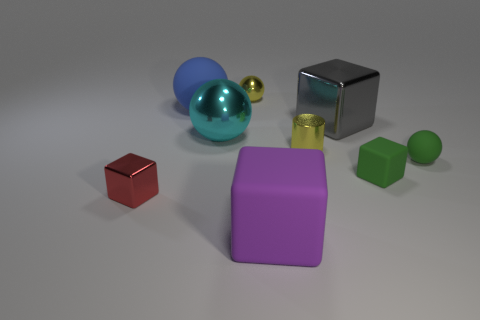There is a big cyan object that is made of the same material as the red object; what shape is it?
Give a very brief answer. Sphere. How many other objects are there of the same shape as the purple thing?
Your answer should be very brief. 3. There is a small yellow metallic object in front of the big matte thing that is left of the large block in front of the tiny green matte sphere; what is its shape?
Your response must be concise. Cylinder. What number of cylinders are big purple rubber things or large gray metal things?
Make the answer very short. 0. There is a metal ball that is to the left of the small yellow sphere; are there any tiny green objects behind it?
Your answer should be very brief. No. There is a purple object; is it the same shape as the tiny yellow thing on the left side of the purple block?
Offer a terse response. No. How many other things are there of the same size as the yellow metal cylinder?
Your response must be concise. 4. How many brown objects are balls or cylinders?
Provide a short and direct response. 0. How many small objects are both in front of the big gray shiny cube and to the left of the tiny green sphere?
Offer a terse response. 3. What is the purple cube in front of the blue rubber sphere on the left side of the matte block to the right of the purple matte block made of?
Ensure brevity in your answer.  Rubber. 